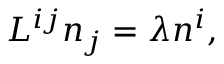Convert formula to latex. <formula><loc_0><loc_0><loc_500><loc_500>L ^ { i j } n _ { j } = \lambda n ^ { i } ,</formula> 